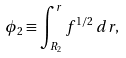<formula> <loc_0><loc_0><loc_500><loc_500>\phi _ { 2 } \equiv \int _ { R _ { 2 } } ^ { r } f ^ { 1 / 2 } \, d r ,</formula> 